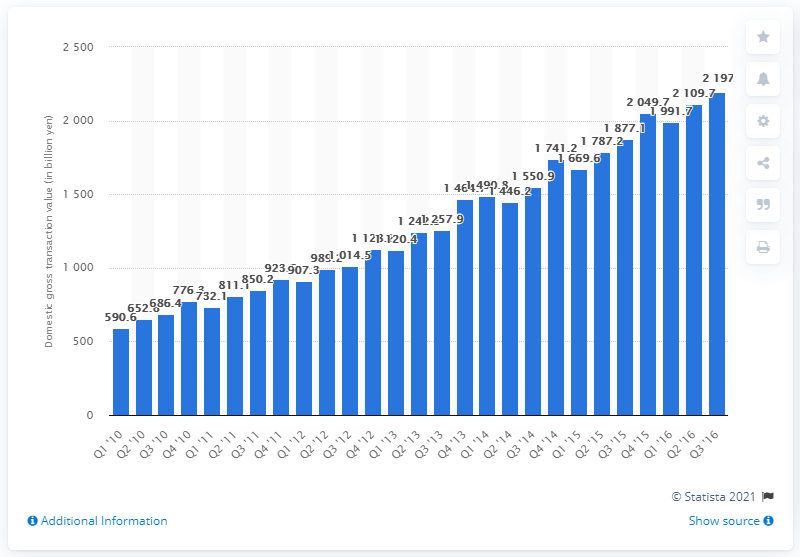Specify some key components in this picture. Rakuten Group's domestic gross transaction value in the third quarter of 2016 was 21,970. 